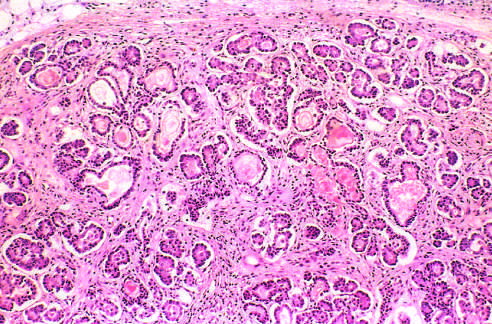what are atrophic and replaced by fibrous tissue?
Answer the question using a single word or phrase. The parenchymal glands 